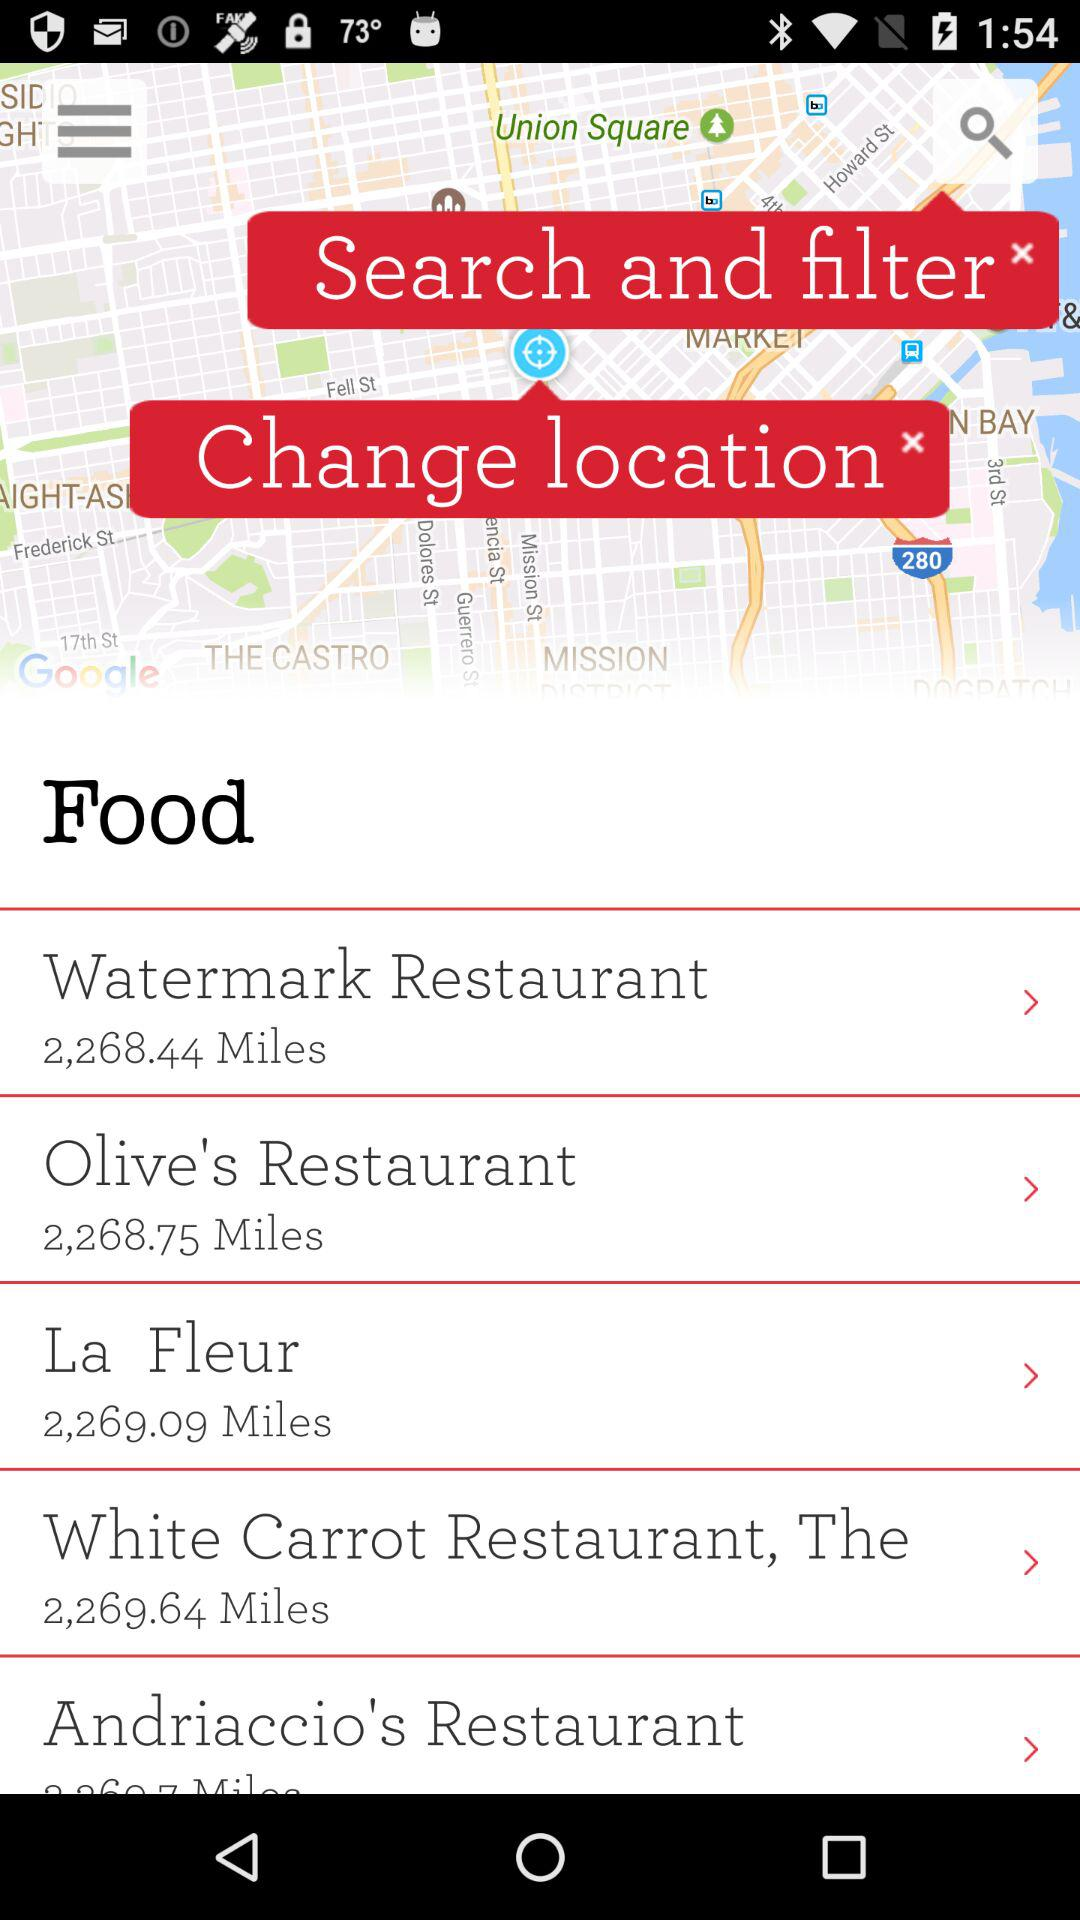What is the distance between Olive's Restaurant and where I am? The distance is 2,268.75 miles. 